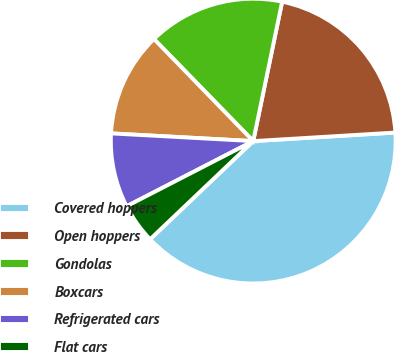<chart> <loc_0><loc_0><loc_500><loc_500><pie_chart><fcel>Covered hoppers<fcel>Open hoppers<fcel>Gondolas<fcel>Boxcars<fcel>Refrigerated cars<fcel>Flat cars<nl><fcel>38.85%<fcel>20.79%<fcel>15.53%<fcel>11.86%<fcel>8.43%<fcel>4.54%<nl></chart> 